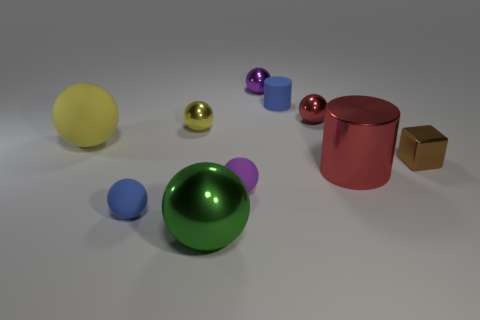Subtract all big spheres. How many spheres are left? 5 Subtract all red cubes. How many blue cylinders are left? 1 Subtract all large purple balls. Subtract all red metal objects. How many objects are left? 8 Add 3 small yellow shiny objects. How many small yellow shiny objects are left? 4 Add 4 big gray metallic things. How many big gray metallic things exist? 4 Subtract all yellow spheres. How many spheres are left? 5 Subtract 0 cyan blocks. How many objects are left? 10 Subtract all cylinders. How many objects are left? 8 Subtract 2 cylinders. How many cylinders are left? 0 Subtract all brown balls. Subtract all brown cubes. How many balls are left? 7 